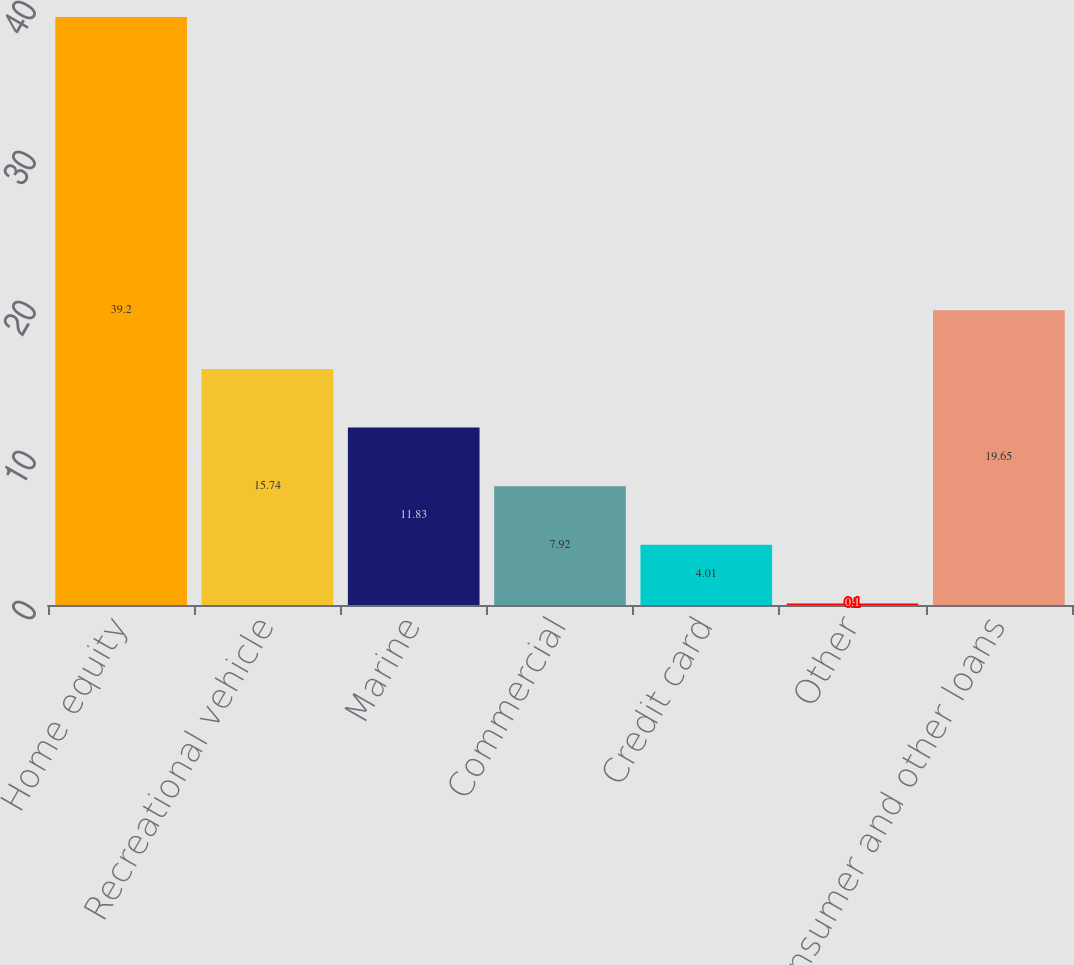Convert chart. <chart><loc_0><loc_0><loc_500><loc_500><bar_chart><fcel>Home equity<fcel>Recreational vehicle<fcel>Marine<fcel>Commercial<fcel>Credit card<fcel>Other<fcel>Total consumer and other loans<nl><fcel>39.2<fcel>15.74<fcel>11.83<fcel>7.92<fcel>4.01<fcel>0.1<fcel>19.65<nl></chart> 